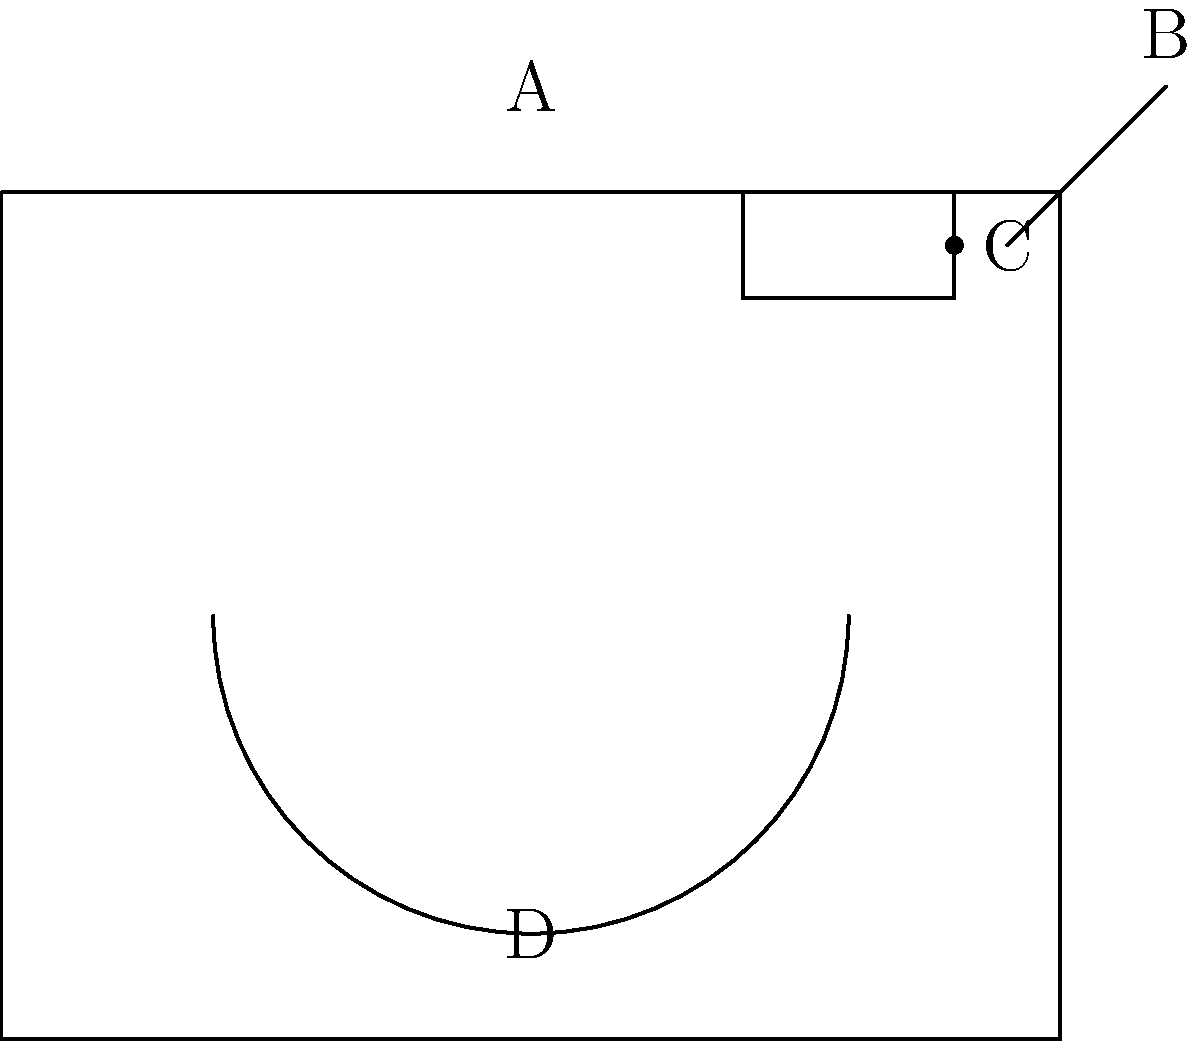Based on the characteristics shown in the image, which type of camera is most likely represented? To identify the type of camera, let's analyze the key features:

1. Overall shape: The camera has a rectangular body, typical of many traditional cameras.

2. Lens (D): The semicircular shape at the front represents a fixed lens, which is characteristic of older camera designs.

3. Viewfinder (A): The small rectangular shape on top is likely a viewfinder, used for framing shots without looking through the lens.

4. Film advance lever (B): The protruding line at the top right is indicative of a film advance lever, used to wind the film after each shot.

5. Shutter button (C): The small circular shape near the top represents the shutter button.

These features, particularly the film advance lever and fixed lens, are hallmarks of a mechanical film camera. The absence of a digital display or other electronic components further supports this conclusion.

Given these characteristics, the camera represented is most likely a 35mm film SLR (Single Lens Reflex) camera, a common type used in the mid to late 20th century before the advent of digital photography.
Answer: 35mm film SLR camera 